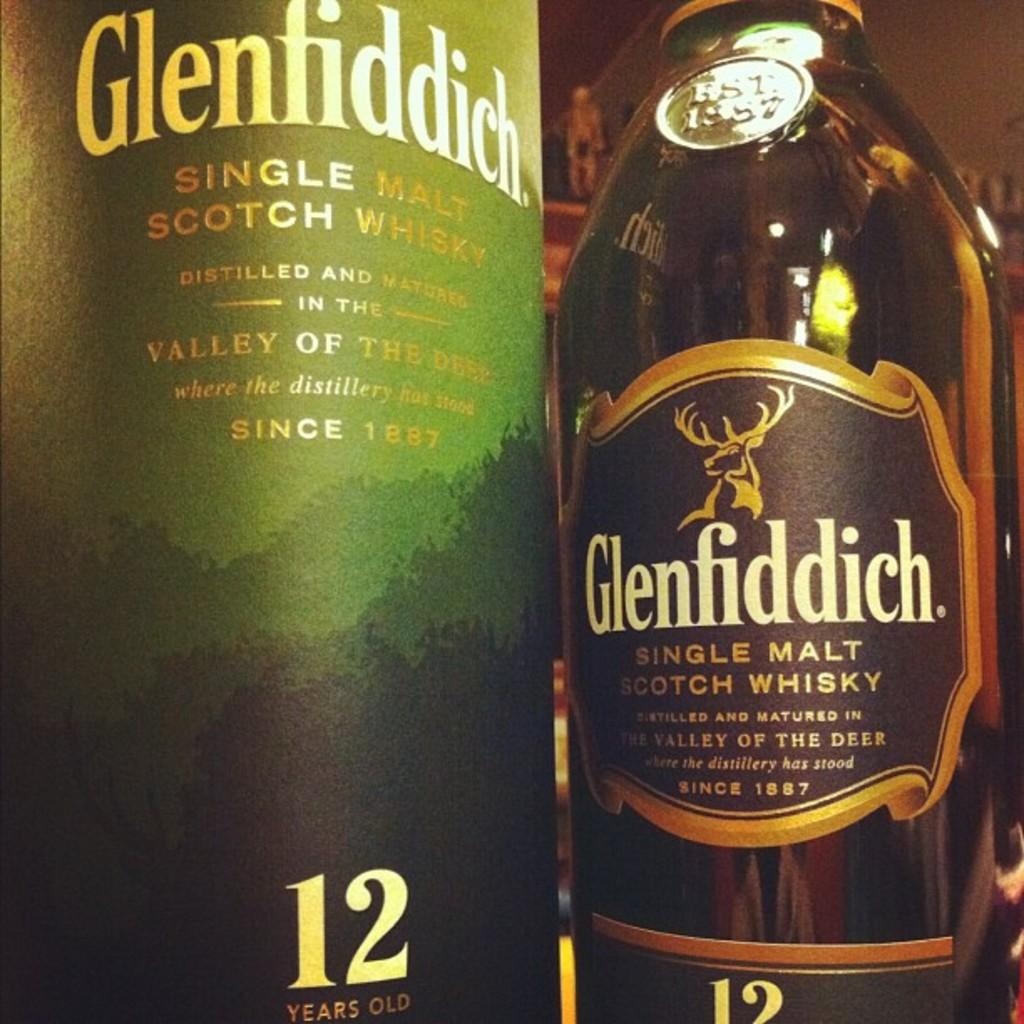<image>
Relay a brief, clear account of the picture shown. A bottle of Glenfiddich is a single malt scotch whisky. 